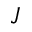<formula> <loc_0><loc_0><loc_500><loc_500>J</formula> 